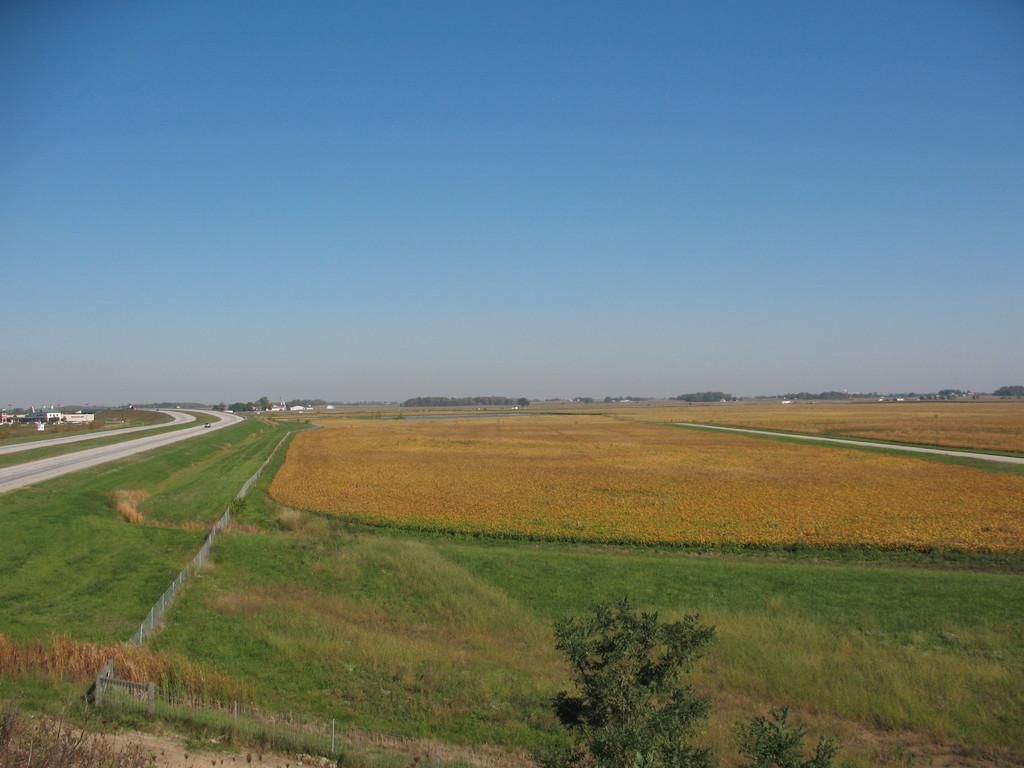What type of terrain is visible in the image? The ground with grass is visible in the image. What type of vegetation can be seen in the image? Plants and trees are visible in the image. What type of barrier is present in the image? There is fencing in the image. What type of path is present in the image? A path is present in the image. What type of structures are visible in the image? Buildings are visible in the image. What part of the natural environment is visible in the image? The sky is visible in the image. How many crates are stacked on the hill in the image? There are no crates or hills present in the image. 